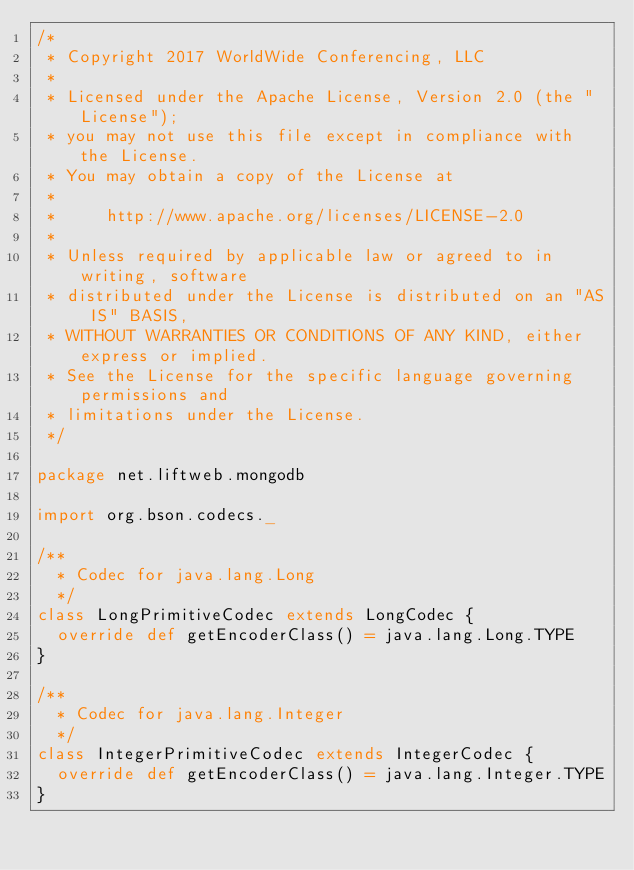<code> <loc_0><loc_0><loc_500><loc_500><_Scala_>/*
 * Copyright 2017 WorldWide Conferencing, LLC
 *
 * Licensed under the Apache License, Version 2.0 (the "License");
 * you may not use this file except in compliance with the License.
 * You may obtain a copy of the License at
 *
 *     http://www.apache.org/licenses/LICENSE-2.0
 *
 * Unless required by applicable law or agreed to in writing, software
 * distributed under the License is distributed on an "AS IS" BASIS,
 * WITHOUT WARRANTIES OR CONDITIONS OF ANY KIND, either express or implied.
 * See the License for the specific language governing permissions and
 * limitations under the License.
 */

package net.liftweb.mongodb

import org.bson.codecs._

/**
  * Codec for java.lang.Long
  */
class LongPrimitiveCodec extends LongCodec {
  override def getEncoderClass() = java.lang.Long.TYPE
}

/**
  * Codec for java.lang.Integer
  */
class IntegerPrimitiveCodec extends IntegerCodec {
  override def getEncoderClass() = java.lang.Integer.TYPE
}
</code> 